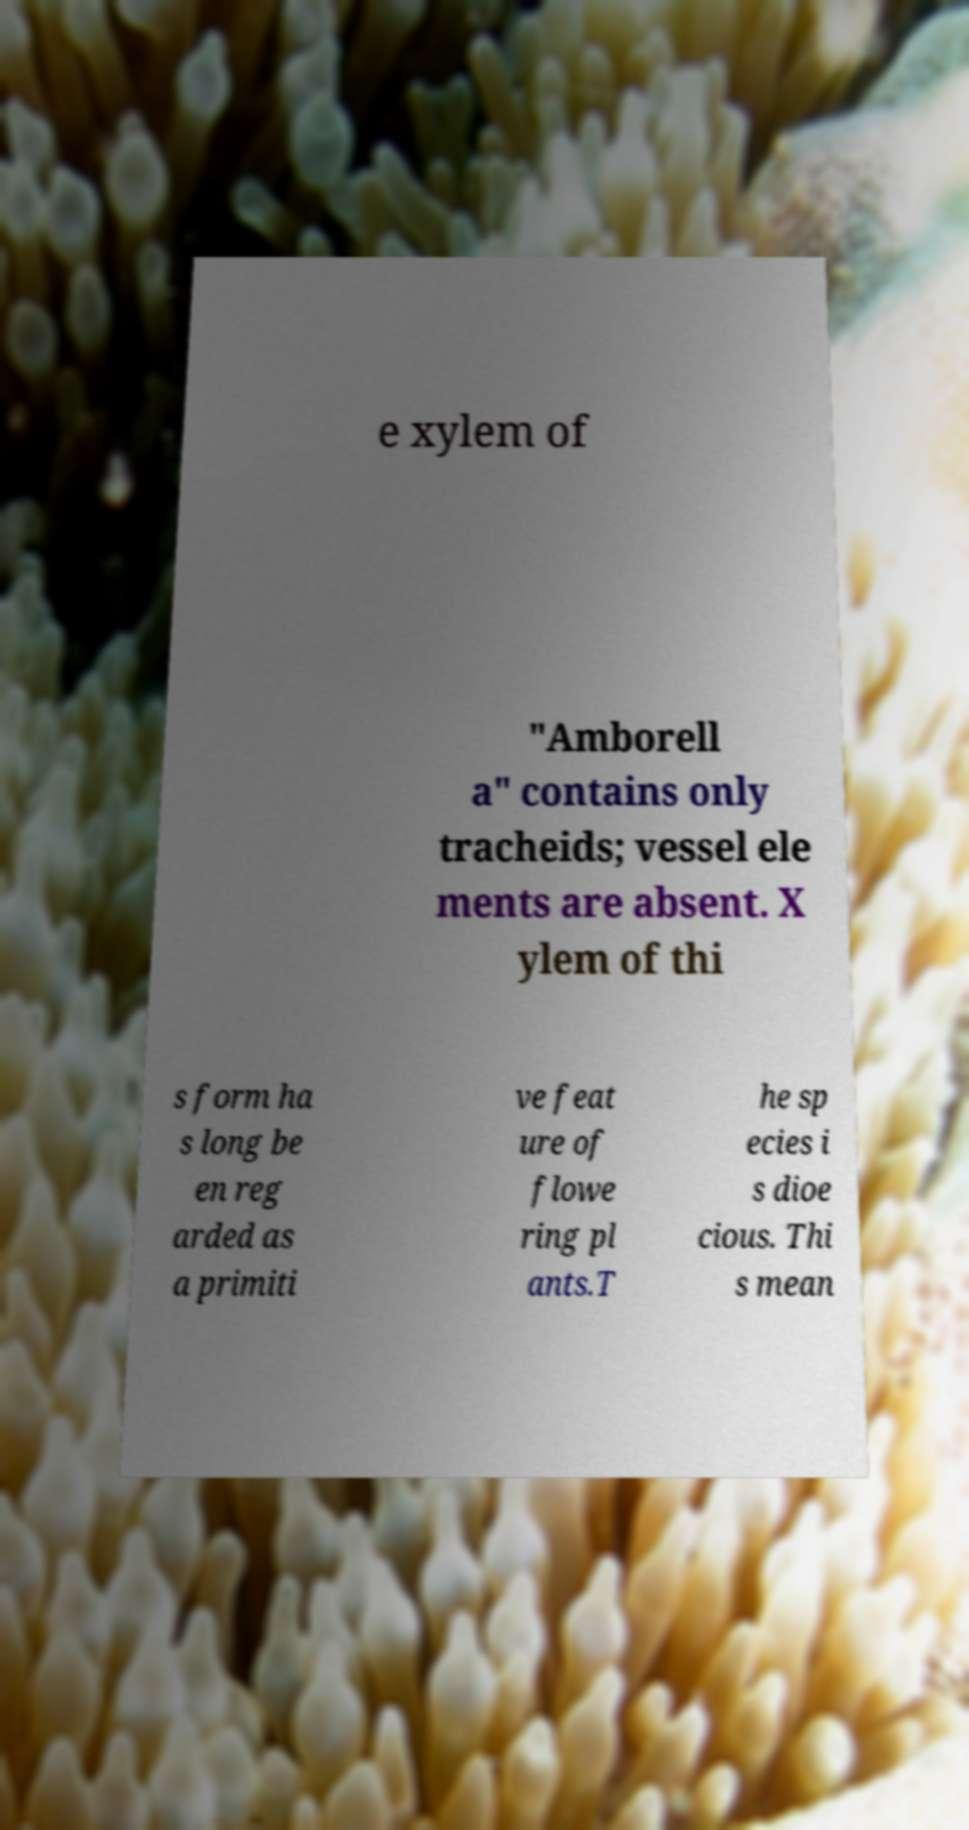There's text embedded in this image that I need extracted. Can you transcribe it verbatim? e xylem of "Amborell a" contains only tracheids; vessel ele ments are absent. X ylem of thi s form ha s long be en reg arded as a primiti ve feat ure of flowe ring pl ants.T he sp ecies i s dioe cious. Thi s mean 